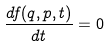<formula> <loc_0><loc_0><loc_500><loc_500>\frac { d f ( q , p , t ) } { d t } = 0</formula> 